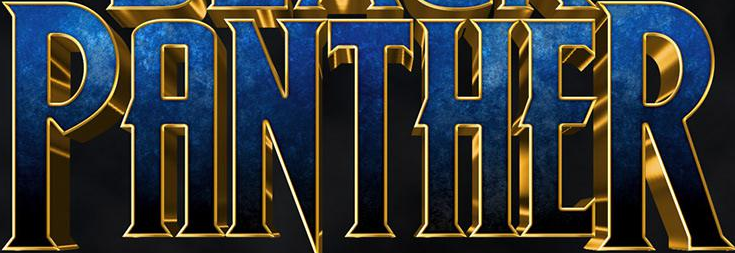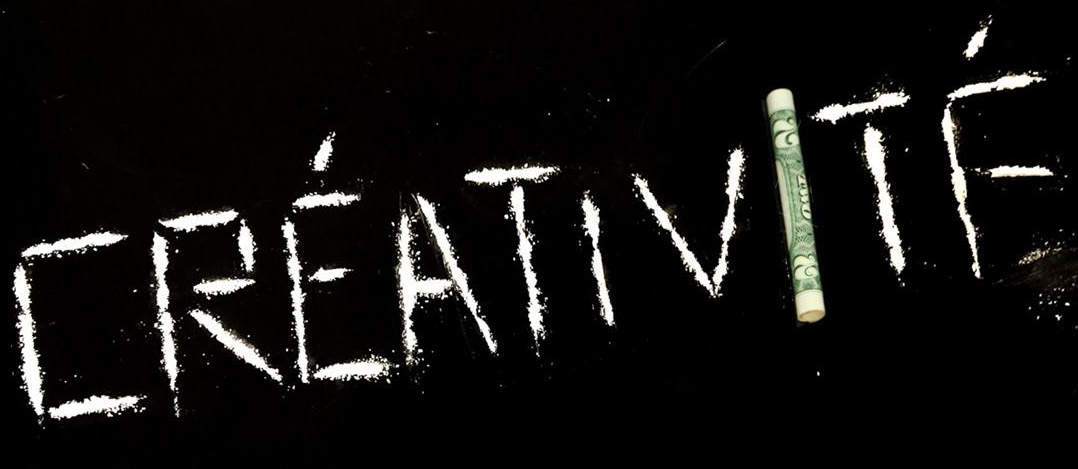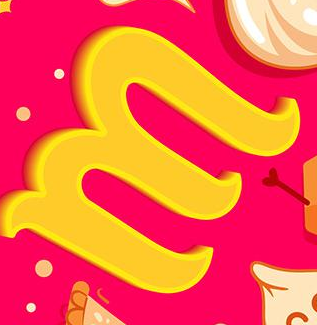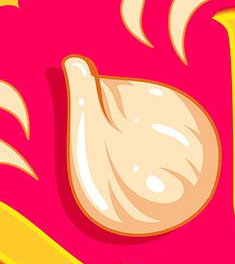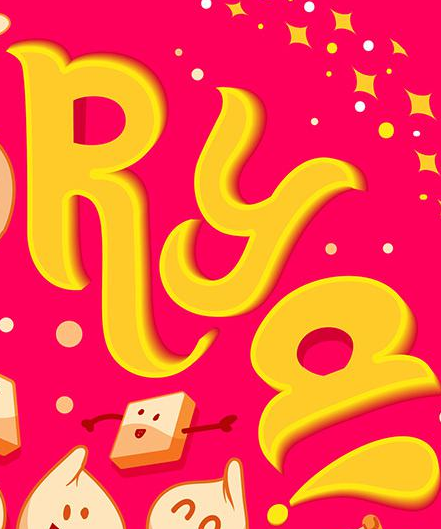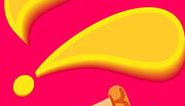What words are shown in these images in order, separated by a semicolon? PANTHER; CRÉATIVITḞ; M; #; RYa; ! 